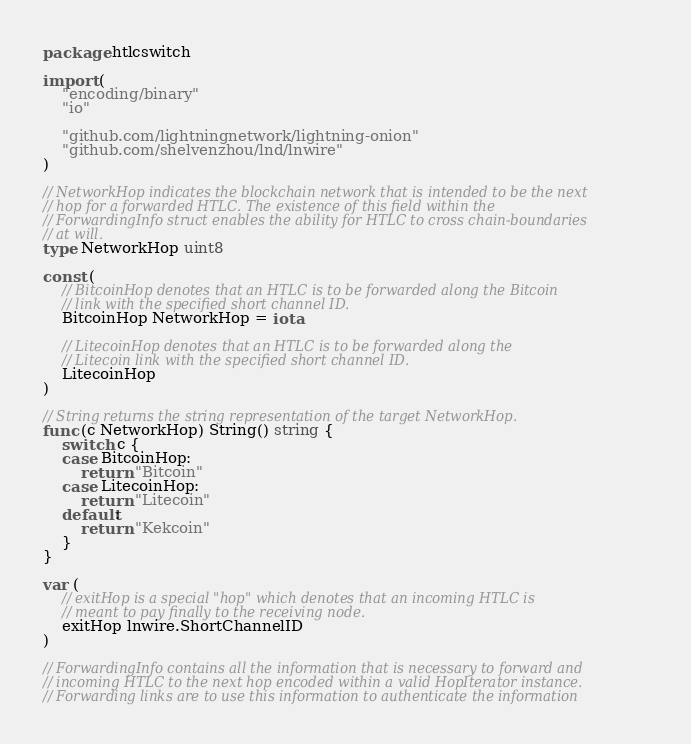<code> <loc_0><loc_0><loc_500><loc_500><_Go_>package htlcswitch

import (
	"encoding/binary"
	"io"

	"github.com/lightningnetwork/lightning-onion"
	"github.com/shelvenzhou/lnd/lnwire"
)

// NetworkHop indicates the blockchain network that is intended to be the next
// hop for a forwarded HTLC. The existence of this field within the
// ForwardingInfo struct enables the ability for HTLC to cross chain-boundaries
// at will.
type NetworkHop uint8

const (
	// BitcoinHop denotes that an HTLC is to be forwarded along the Bitcoin
	// link with the specified short channel ID.
	BitcoinHop NetworkHop = iota

	// LitecoinHop denotes that an HTLC is to be forwarded along the
	// Litecoin link with the specified short channel ID.
	LitecoinHop
)

// String returns the string representation of the target NetworkHop.
func (c NetworkHop) String() string {
	switch c {
	case BitcoinHop:
		return "Bitcoin"
	case LitecoinHop:
		return "Litecoin"
	default:
		return "Kekcoin"
	}
}

var (
	// exitHop is a special "hop" which denotes that an incoming HTLC is
	// meant to pay finally to the receiving node.
	exitHop lnwire.ShortChannelID
)

// ForwardingInfo contains all the information that is necessary to forward and
// incoming HTLC to the next hop encoded within a valid HopIterator instance.
// Forwarding links are to use this information to authenticate the information</code> 